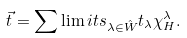<formula> <loc_0><loc_0><loc_500><loc_500>\vec { t } = \sum \lim i t s _ { \lambda \in \hat { W } } t _ { \lambda } \chi ^ { \lambda } _ { H } .</formula> 